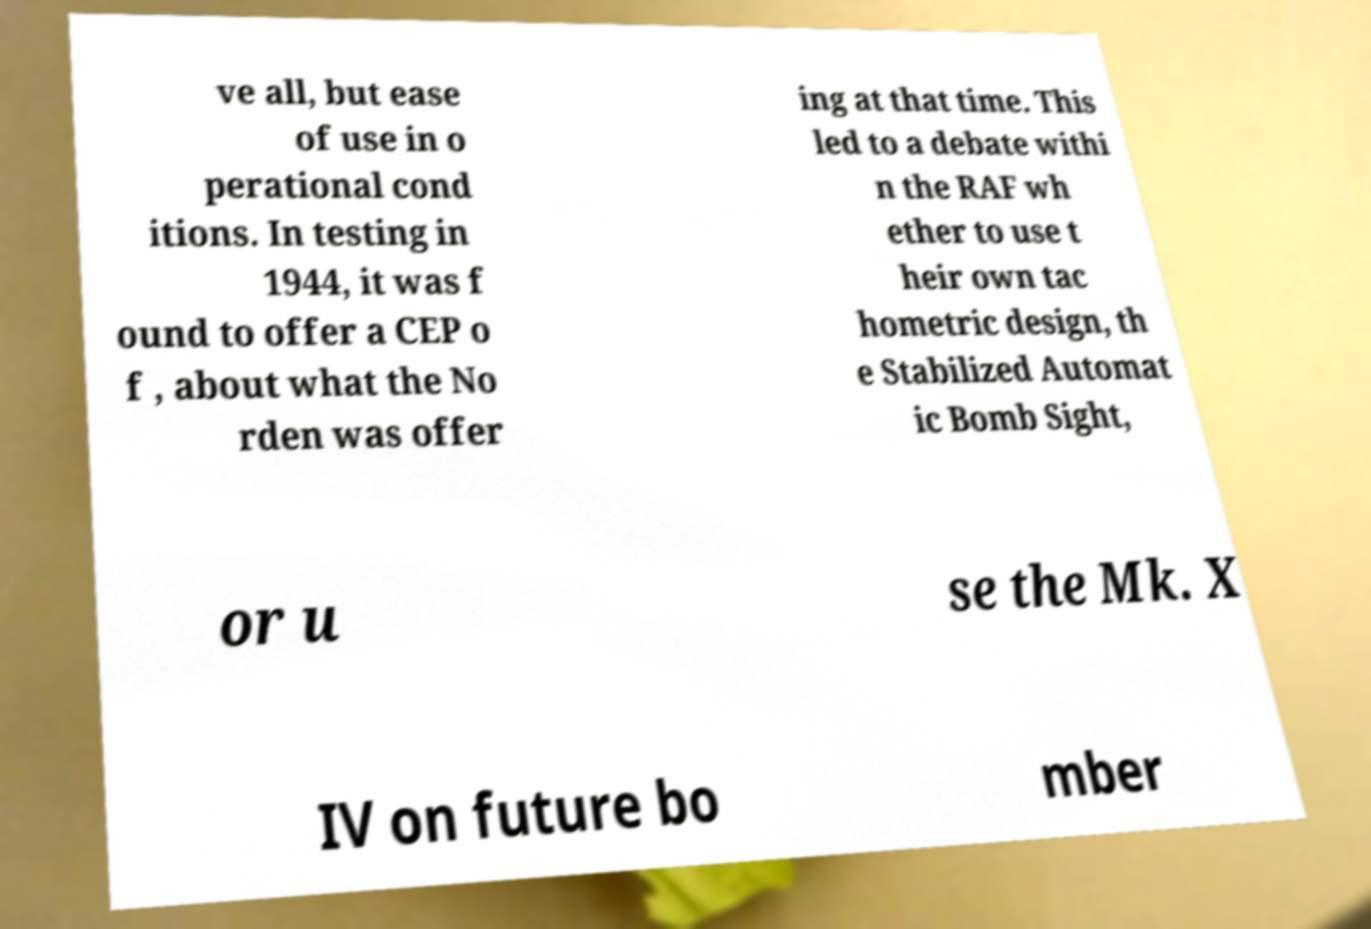Please read and relay the text visible in this image. What does it say? ve all, but ease of use in o perational cond itions. In testing in 1944, it was f ound to offer a CEP o f , about what the No rden was offer ing at that time. This led to a debate withi n the RAF wh ether to use t heir own tac hometric design, th e Stabilized Automat ic Bomb Sight, or u se the Mk. X IV on future bo mber 